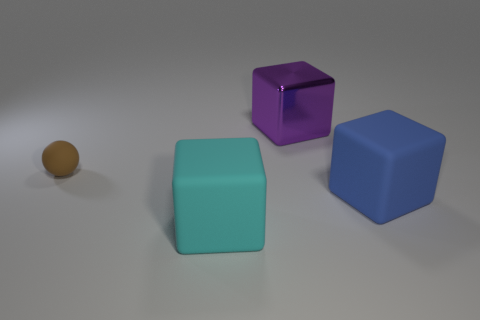What is the shape of the tiny rubber object?
Provide a succinct answer. Sphere. There is a big matte object on the right side of the large cube that is behind the large blue matte thing; what color is it?
Ensure brevity in your answer.  Blue. There is a object that is behind the blue matte cube and to the right of the brown rubber object; what material is it made of?
Provide a short and direct response. Metal. Are there any purple shiny objects that have the same size as the blue rubber cube?
Provide a short and direct response. Yes. There is a purple thing that is the same size as the cyan matte thing; what is it made of?
Give a very brief answer. Metal. There is a blue matte thing; what number of matte things are to the left of it?
Keep it short and to the point. 2. There is a thing that is behind the small brown thing; is it the same shape as the big blue object?
Ensure brevity in your answer.  Yes. Is there a small rubber object of the same shape as the big purple shiny thing?
Your answer should be compact. No. There is a rubber thing to the left of the big cube that is to the left of the purple cube; what shape is it?
Make the answer very short. Sphere. What number of purple cubes are made of the same material as the blue block?
Ensure brevity in your answer.  0. 